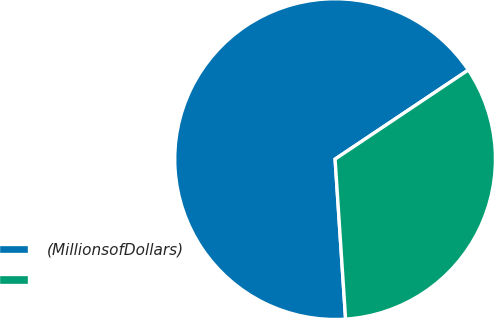<chart> <loc_0><loc_0><loc_500><loc_500><pie_chart><fcel>(MillionsofDollars)<fcel>Unnamed: 1<nl><fcel>66.66%<fcel>33.34%<nl></chart> 